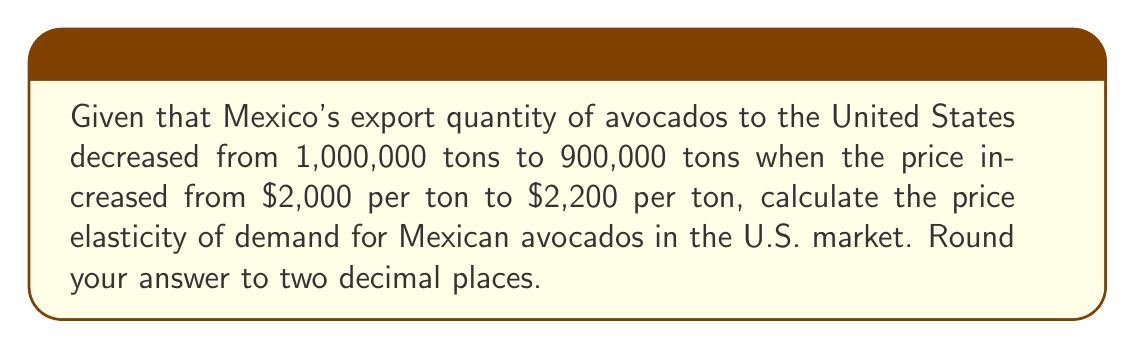Show me your answer to this math problem. To calculate the price elasticity of demand, we'll use the following formula:

$$ \text{Price Elasticity of Demand} = \frac{\text{Percentage change in quantity}}{\text{Percentage change in price}} $$

Step 1: Calculate the percentage change in quantity
$$ \text{Percentage change in quantity} = \frac{900,000 - 1,000,000}{1,000,000} \times 100 = -10\% $$

Step 2: Calculate the percentage change in price
$$ \text{Percentage change in price} = \frac{2,200 - 2,000}{2,000} \times 100 = 10\% $$

Step 3: Calculate the price elasticity of demand
$$ \text{Price Elasticity of Demand} = \frac{-10\%}{10\%} = -1 $$

Step 4: Take the absolute value and round to two decimal places
$$ |\text{Price Elasticity of Demand}| = 1.00 $$

The negative sign is typically omitted in the final answer, as it's understood that the price elasticity of demand is usually negative (quantity demanded decreases as price increases).
Answer: 1.00 